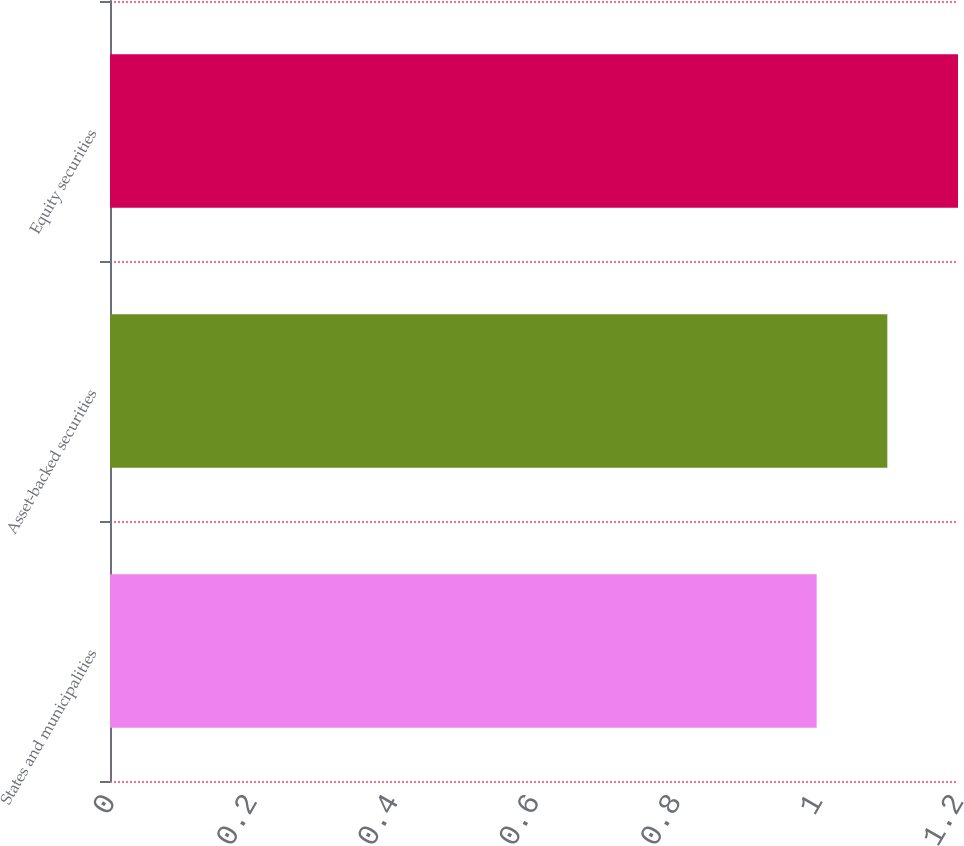Convert chart to OTSL. <chart><loc_0><loc_0><loc_500><loc_500><bar_chart><fcel>States and municipalities<fcel>Asset-backed securities<fcel>Equity securities<nl><fcel>1<fcel>1.1<fcel>1.2<nl></chart> 